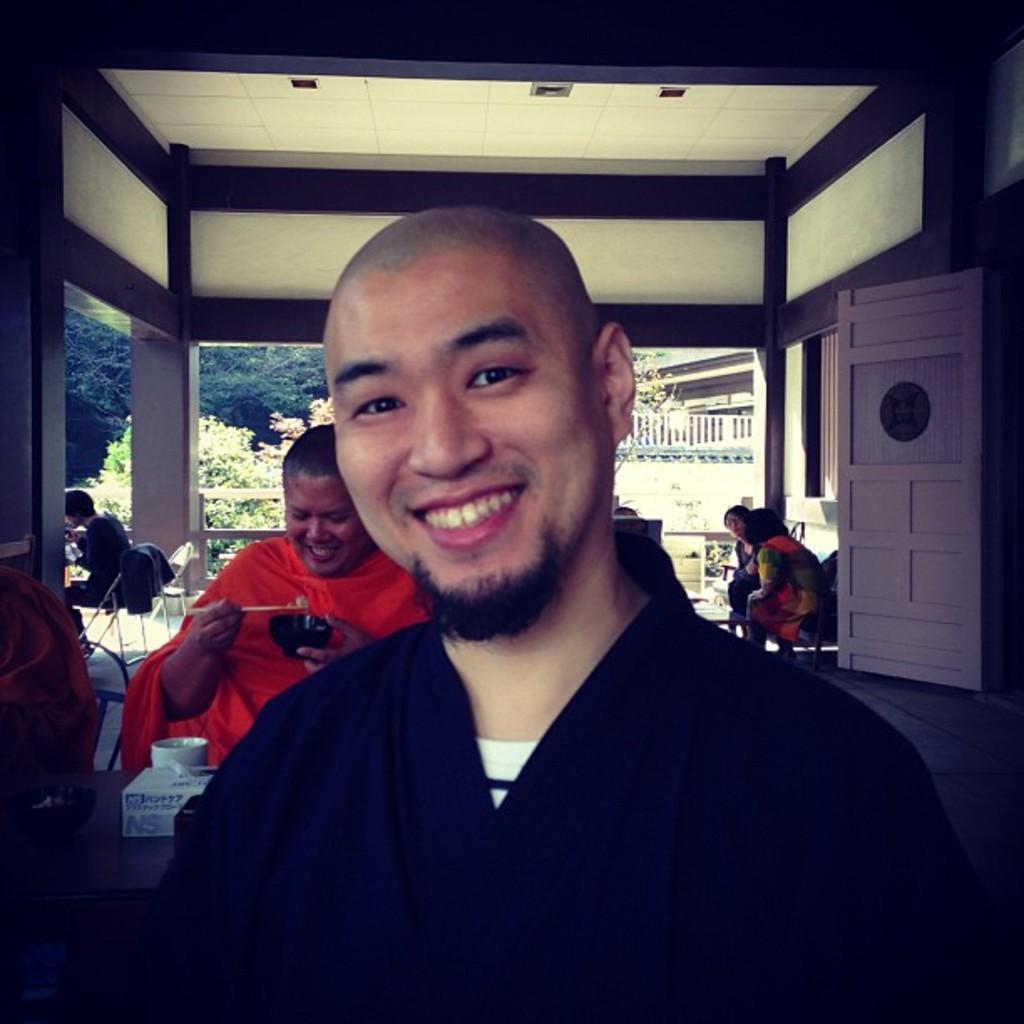In one or two sentences, can you explain what this image depicts? There is a person in black color t-shirt, smiling. In the background, there are other persons sitting. Above them, there is a roof of a building, there is a white color door, there are trees and there are plants. 